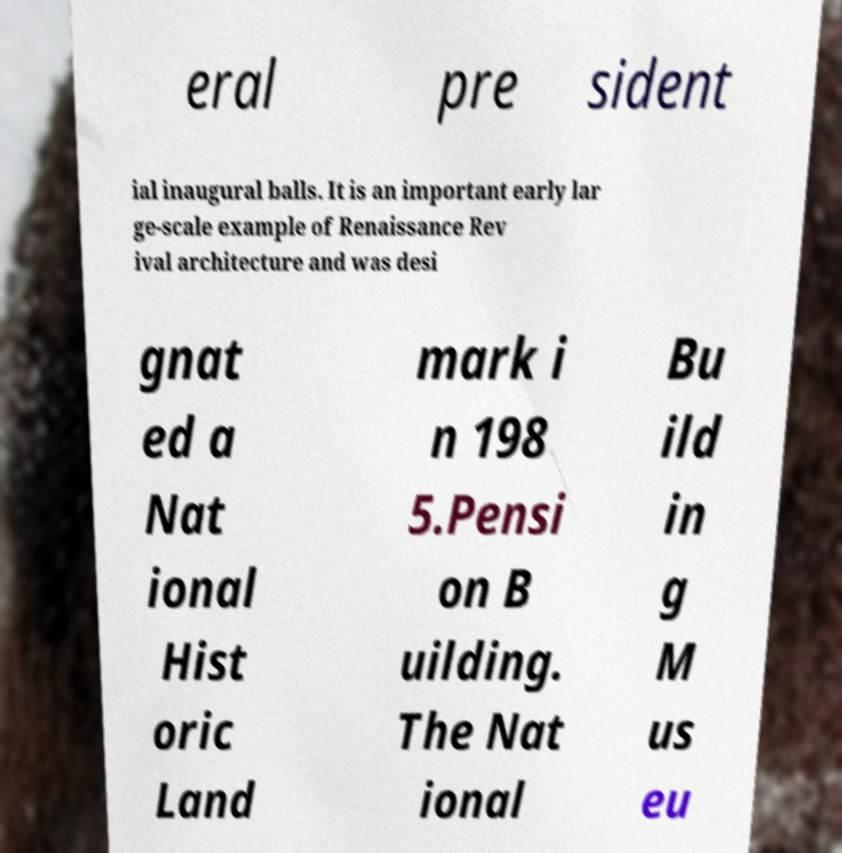I need the written content from this picture converted into text. Can you do that? eral pre sident ial inaugural balls. It is an important early lar ge-scale example of Renaissance Rev ival architecture and was desi gnat ed a Nat ional Hist oric Land mark i n 198 5.Pensi on B uilding. The Nat ional Bu ild in g M us eu 